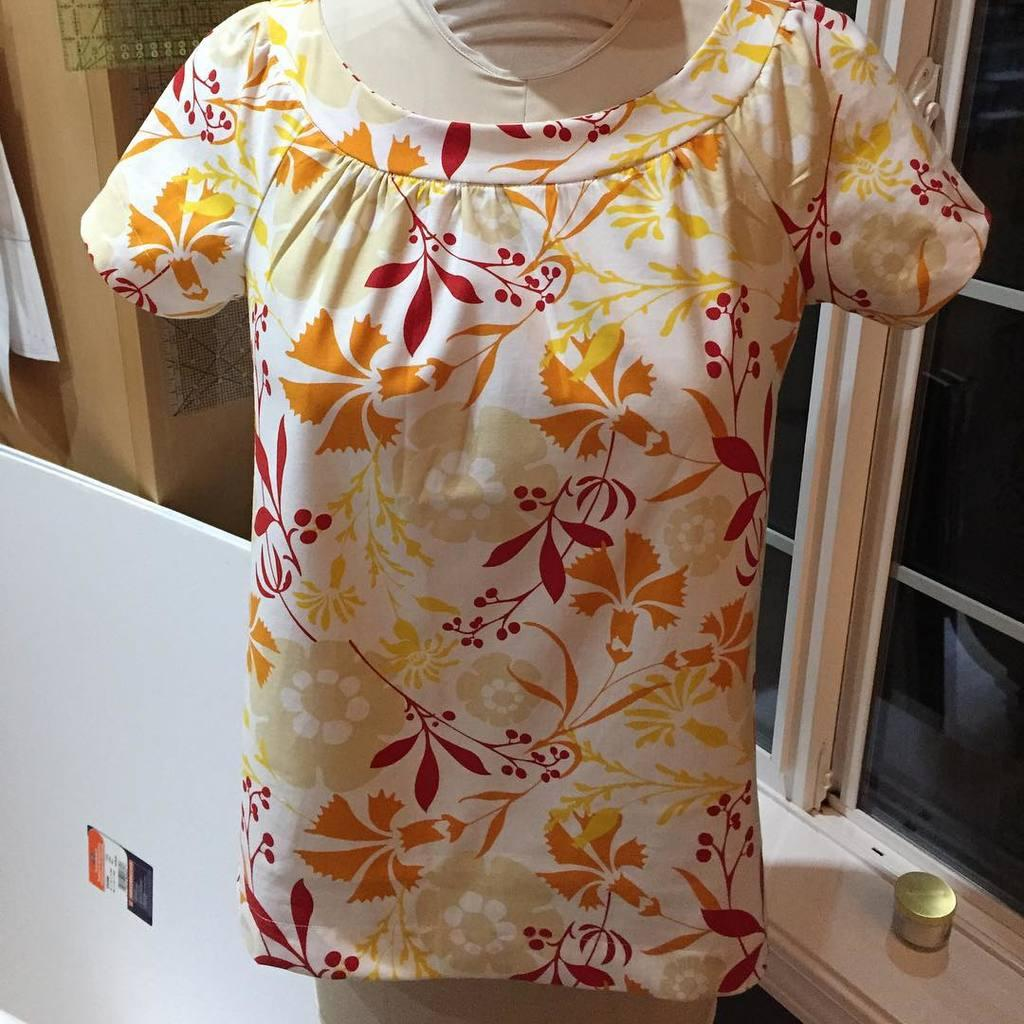What type of clothing is in the image? There is a dress in the image. What colors can be seen on the dress? The dress has white, yellow, orange, and red colors. What is located behind the dress? There is a white object behind the dress. What architectural feature is visible in the image? There are windows visible in the image. What color is the brown object in the image? There is a brown object in the image, but the facts do not specify its color. What is the value of the dress in the image? The value of the dress cannot be determined from the image alone, as it depends on various factors such as the brand, material, and condition. --- 